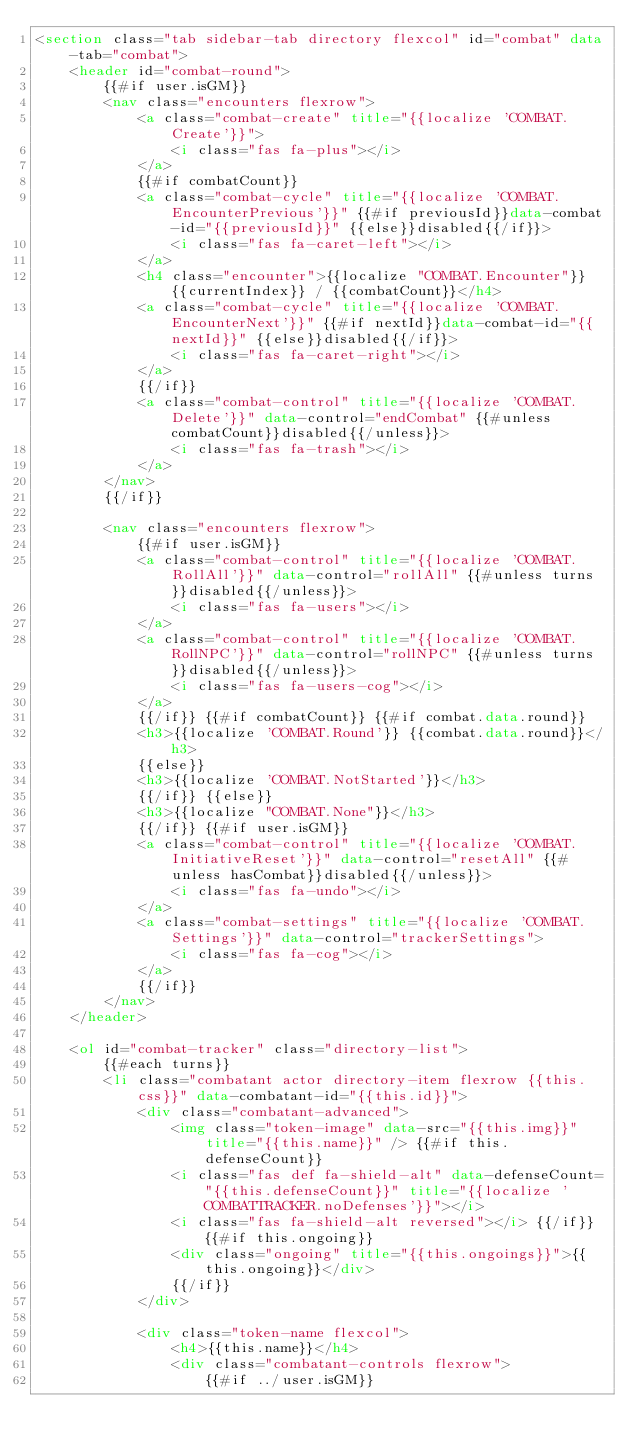Convert code to text. <code><loc_0><loc_0><loc_500><loc_500><_HTML_><section class="tab sidebar-tab directory flexcol" id="combat" data-tab="combat">
    <header id="combat-round">
        {{#if user.isGM}}
        <nav class="encounters flexrow">
            <a class="combat-create" title="{{localize 'COMBAT.Create'}}">
                <i class="fas fa-plus"></i>
            </a>
            {{#if combatCount}}
            <a class="combat-cycle" title="{{localize 'COMBAT.EncounterPrevious'}}" {{#if previousId}}data-combat-id="{{previousId}}" {{else}}disabled{{/if}}>
                <i class="fas fa-caret-left"></i>
            </a>
            <h4 class="encounter">{{localize "COMBAT.Encounter"}} {{currentIndex}} / {{combatCount}}</h4>
            <a class="combat-cycle" title="{{localize 'COMBAT.EncounterNext'}}" {{#if nextId}}data-combat-id="{{nextId}}" {{else}}disabled{{/if}}>
                <i class="fas fa-caret-right"></i>
            </a>
            {{/if}}
            <a class="combat-control" title="{{localize 'COMBAT.Delete'}}" data-control="endCombat" {{#unless combatCount}}disabled{{/unless}}>
                <i class="fas fa-trash"></i>
            </a>
        </nav>
        {{/if}}

        <nav class="encounters flexrow">
            {{#if user.isGM}}
            <a class="combat-control" title="{{localize 'COMBAT.RollAll'}}" data-control="rollAll" {{#unless turns}}disabled{{/unless}}>
                <i class="fas fa-users"></i>
            </a>
            <a class="combat-control" title="{{localize 'COMBAT.RollNPC'}}" data-control="rollNPC" {{#unless turns}}disabled{{/unless}}>
                <i class="fas fa-users-cog"></i>
            </a>
            {{/if}} {{#if combatCount}} {{#if combat.data.round}}
            <h3>{{localize 'COMBAT.Round'}} {{combat.data.round}}</h3>
            {{else}}
            <h3>{{localize 'COMBAT.NotStarted'}}</h3>
            {{/if}} {{else}}
            <h3>{{localize "COMBAT.None"}}</h3>
            {{/if}} {{#if user.isGM}}
            <a class="combat-control" title="{{localize 'COMBAT.InitiativeReset'}}" data-control="resetAll" {{#unless hasCombat}}disabled{{/unless}}>
                <i class="fas fa-undo"></i>
            </a>
            <a class="combat-settings" title="{{localize 'COMBAT.Settings'}}" data-control="trackerSettings">
                <i class="fas fa-cog"></i>
            </a>
            {{/if}}
        </nav>
    </header>

    <ol id="combat-tracker" class="directory-list">
        {{#each turns}}
        <li class="combatant actor directory-item flexrow {{this.css}}" data-combatant-id="{{this.id}}">
            <div class="combatant-advanced">
                <img class="token-image" data-src="{{this.img}}" title="{{this.name}}" /> {{#if this.defenseCount}}
                <i class="fas def fa-shield-alt" data-defenseCount="{{this.defenseCount}}" title="{{localize 'COMBATTRACKER.noDefenses'}}"></i>
                <i class="fas fa-shield-alt reversed"></i> {{/if}} {{#if this.ongoing}}
                <div class="ongoing" title="{{this.ongoings}}">{{this.ongoing}}</div>
                {{/if}}
            </div>

            <div class="token-name flexcol">
                <h4>{{this.name}}</h4>
                <div class="combatant-controls flexrow">
                    {{#if ../user.isGM}}</code> 